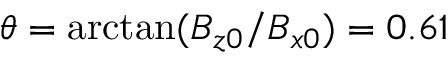<formula> <loc_0><loc_0><loc_500><loc_500>\theta = \arctan ( B _ { z 0 } / B _ { x 0 } ) = 0 . 6 1</formula> 